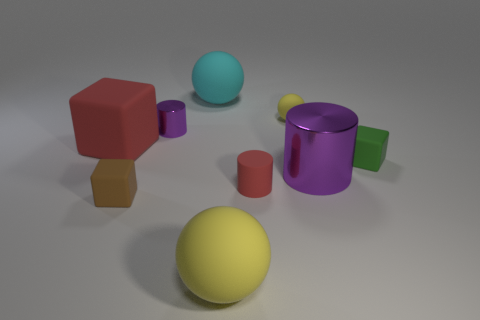What is the material of the cube that is the same color as the matte cylinder?
Your answer should be compact. Rubber. There is a block to the right of the red object in front of the big object that is to the left of the big cyan ball; what is its size?
Offer a terse response. Small. What is the color of the cube that is to the right of the big red thing and behind the brown matte cube?
Keep it short and to the point. Green. How many small yellow objects are there?
Make the answer very short. 1. Do the tiny green cube and the tiny purple thing have the same material?
Your answer should be very brief. No. Is the size of the yellow sphere that is behind the small purple object the same as the thing that is behind the tiny yellow rubber object?
Offer a terse response. No. Are there fewer yellow matte objects than small yellow rubber spheres?
Ensure brevity in your answer.  No. How many rubber things are large purple cylinders or green cylinders?
Offer a terse response. 0. There is a small block on the right side of the small brown matte cube; are there any shiny things that are in front of it?
Give a very brief answer. Yes. Are the red cube behind the small matte cylinder and the small brown thing made of the same material?
Make the answer very short. Yes. 